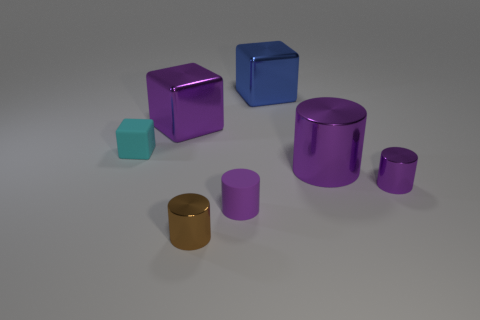What is the material of the small cyan block?
Your answer should be compact. Rubber. There is a rubber object on the right side of the small brown object; what is its size?
Your response must be concise. Small. How many blue cubes are left of the cylinder that is behind the small purple metal cylinder?
Offer a terse response. 1. There is a tiny object that is in front of the tiny matte cylinder; is its shape the same as the matte thing right of the cyan matte block?
Give a very brief answer. Yes. How many large metal cubes are in front of the blue cube and to the right of the purple block?
Provide a short and direct response. 0. Is there a block of the same color as the large metallic cylinder?
Make the answer very short. Yes. There is another shiny object that is the same size as the brown shiny thing; what shape is it?
Keep it short and to the point. Cylinder. There is a large blue shiny block; are there any small purple shiny things behind it?
Offer a very short reply. No. Does the large cube that is in front of the blue metallic object have the same material as the large purple object in front of the tiny block?
Provide a short and direct response. Yes. What number of purple metallic objects have the same size as the rubber cylinder?
Ensure brevity in your answer.  1. 